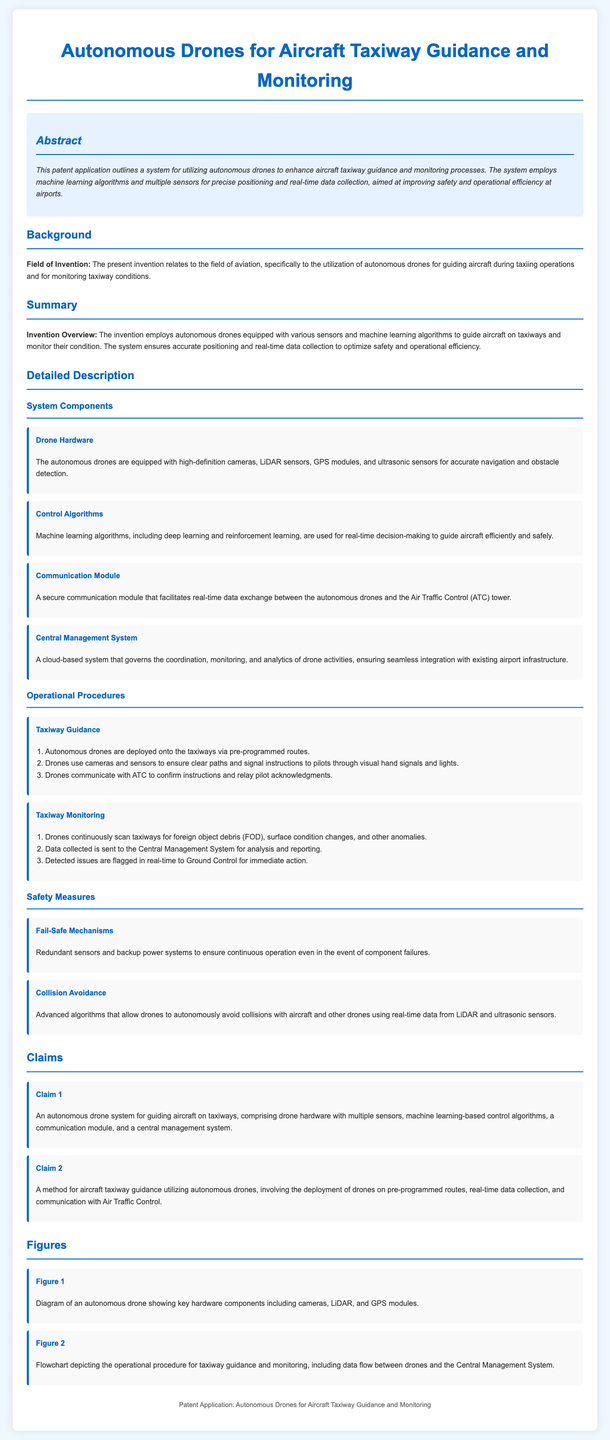What is the field of invention? The field of invention is specified in the background section of the document, which states it relates to aviation and autonomous drones for taxiing operations and monitoring taxiway conditions.
Answer: Aviation What are the key hardware components of the drone? The detailed description outlines the drone hardware components, specifically mentioning high-definition cameras, LiDAR sensors, GPS modules, and ultrasonic sensors.
Answer: High-definition cameras, LiDAR sensors, GPS modules, ultrasonic sensors What type of algorithms are used for control? The section on control algorithms in the detailed description specifies that machine learning algorithms, including deep learning and reinforcement learning, are utilized.
Answer: Machine learning algorithms How many claims are listed in the document? The claims section contains two claims, detailed in the Claims section of the document.
Answer: Two What is the purpose of the Central Management System? The detailed description mentions that the Central Management System is responsible for governing the coordination, monitoring, and analytics of drone activities.
Answer: Coordination, monitoring, and analytics What safety measure involves collision avoidance? The safety measures section specifies advanced algorithms that allow drones to autonomously avoid collisions.
Answer: Collision avoidance How many steps are involved in the taxiway monitoring procedure? The operational procedures section describes three steps in the taxiway monitoring procedure detailed in the document.
Answer: Three What is the main goal of the invention? The summary section emphasizes that the main goal of the invention is to enhance aircraft taxiway guidance and monitoring for safety and operational efficiency.
Answer: Enhance safety and operational efficiency 